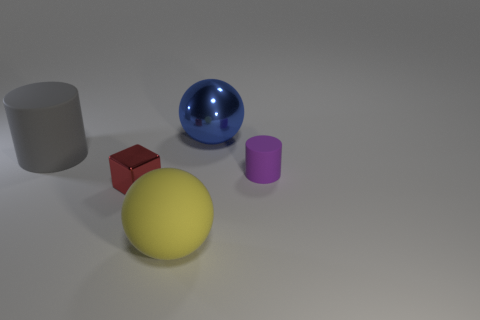What shape is the thing that is both on the right side of the red metal object and in front of the purple matte object?
Your answer should be very brief. Sphere. There is a cylinder that is behind the thing right of the blue object; what is its material?
Your response must be concise. Rubber. Is the number of large red cubes greater than the number of blue spheres?
Provide a succinct answer. No. Is the color of the block the same as the small cylinder?
Your answer should be compact. No. There is another ball that is the same size as the metal ball; what material is it?
Your answer should be compact. Rubber. Does the red object have the same material as the large blue ball?
Provide a short and direct response. Yes. What number of balls have the same material as the small cylinder?
Offer a terse response. 1. What number of things are cylinders left of the tiny purple rubber object or rubber things in front of the large gray cylinder?
Provide a short and direct response. 3. Are there more large rubber cylinders on the right side of the red metal thing than rubber spheres behind the yellow ball?
Offer a very short reply. No. There is a cylinder that is to the right of the blue metal object; what color is it?
Give a very brief answer. Purple. 